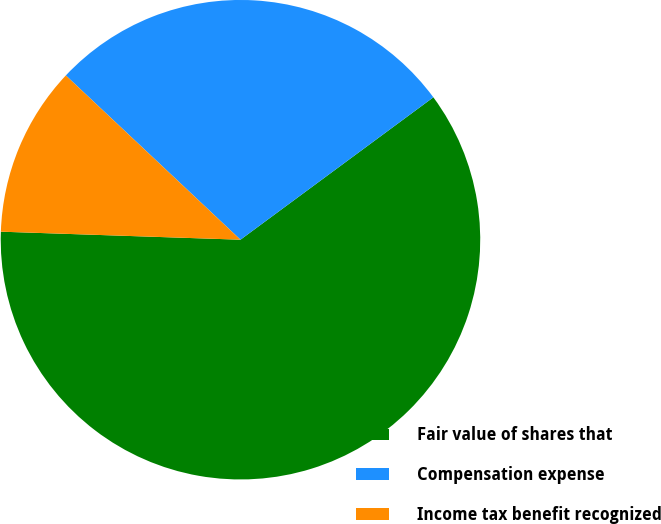Convert chart to OTSL. <chart><loc_0><loc_0><loc_500><loc_500><pie_chart><fcel>Fair value of shares that<fcel>Compensation expense<fcel>Income tax benefit recognized<nl><fcel>60.66%<fcel>27.87%<fcel>11.48%<nl></chart> 